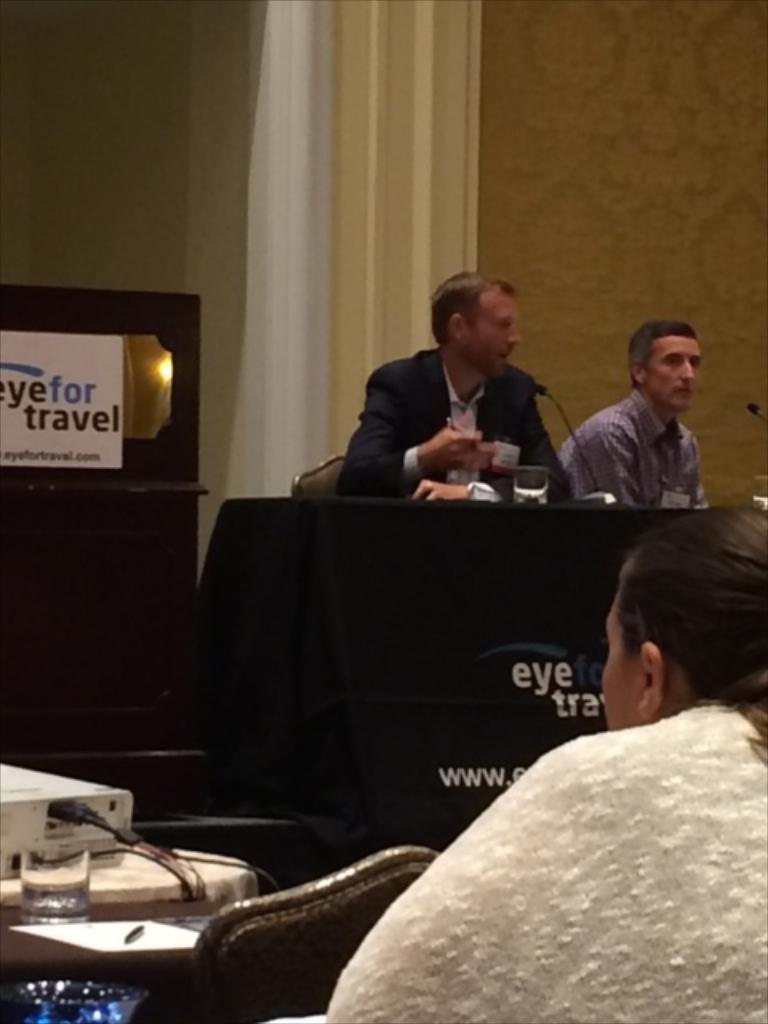In one or two sentences, can you explain what this image depicts? In this picture we can see two men sitting on chair and in front of them on table we have glass with water in it, mic and beside to them we have a mirror, banner and in front of them we can see a women, projector, paper, pen and in the background we can see wall, curtains. 